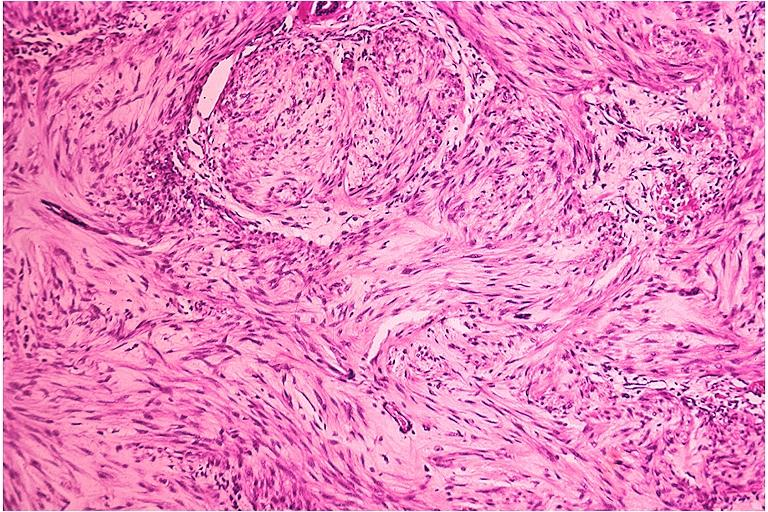s oral present?
Answer the question using a single word or phrase. Yes 